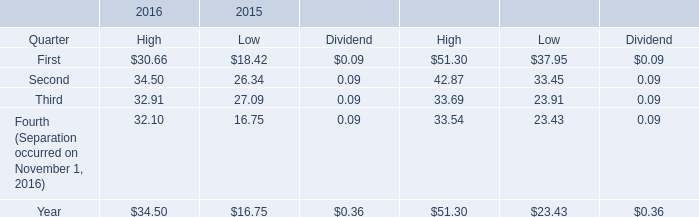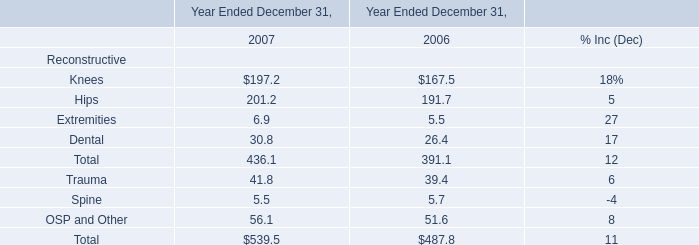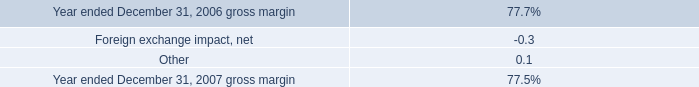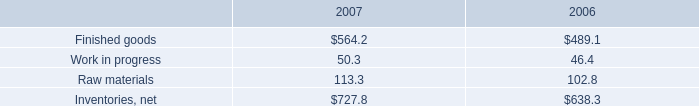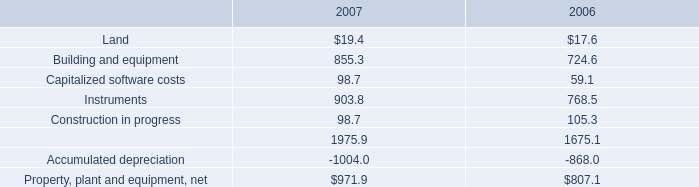As As the chart 4 shows,which year is the value for Building and equipment greater than 855? 
Answer: 2007. As As the chart 4 shows,what is the value for the Instruments in the year where the value for Building and equipment is greater than 855? 
Answer: 903.8. 